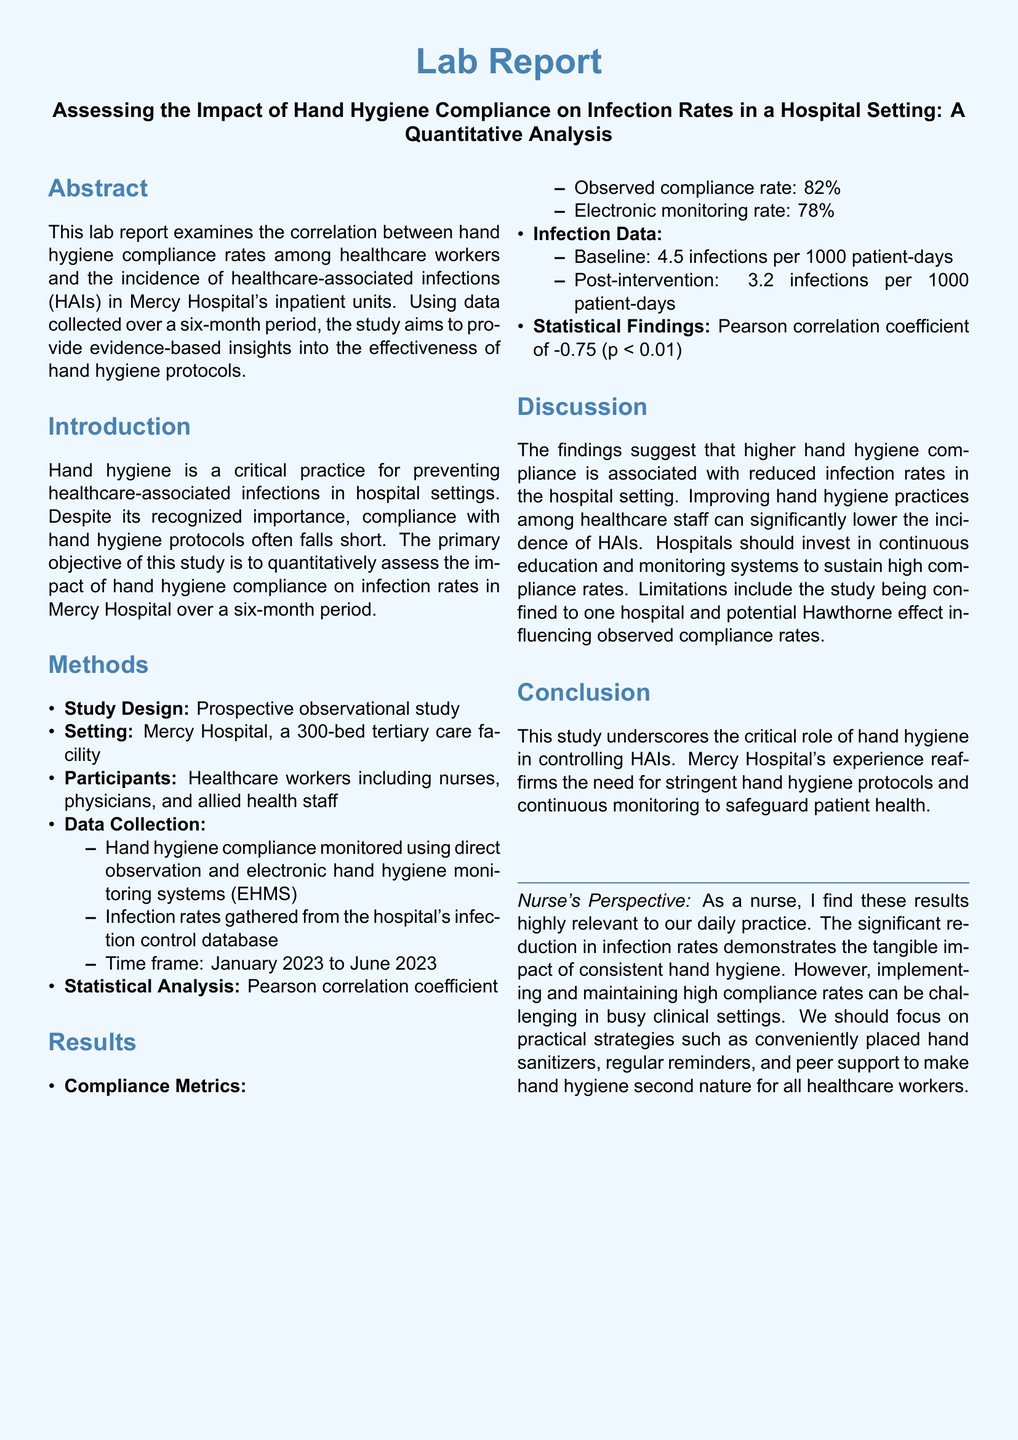what is the primary objective of the study? The primary objective of the study is to quantitatively assess the impact of hand hygiene compliance on infection rates in Mercy Hospital over a six-month period.
Answer: to quantitatively assess the impact of hand hygiene compliance on infection rates what is the observed hand hygiene compliance rate? The observed compliance rate is directly stated in the results section of the document.
Answer: 82% what was the infection rate per 1000 patient-days post-intervention? The post-intervention infection rate is directly mentioned in the results section.
Answer: 3.2 infections per 1000 patient-days what statistical method was used for analysis? The statistical method is identified in the methods section of the document.
Answer: Pearson correlation coefficient what does a Pearson correlation coefficient of -0.75 indicate? The coefficient indicates the strength and direction of a linear relationship between hand hygiene compliance and infection rates, which is discussed in the results section.
Answer: strong negative correlation what limitation is mentioned in the study? The limitation is highlighted in the discussion section and refers to the scope of the study.
Answer: confined to one hospital what is the significance level (p-value) reported in the study? The significance level (p-value) is specified in the results section along with the correlation coefficient.
Answer: p < 0.01 what type of study design was used? The study design is described in the methods section of the document.
Answer: Prospective observational study what is the setting of the study? The setting refers to the specific location where the study was conducted, mentioned in the methods section.
Answer: Mercy Hospital what is suggested as a key strategy for improving hand hygiene compliance? Suggested strategies are included in the nurse's perspective at the end of the report.
Answer: conveniently placed hand sanitizers 